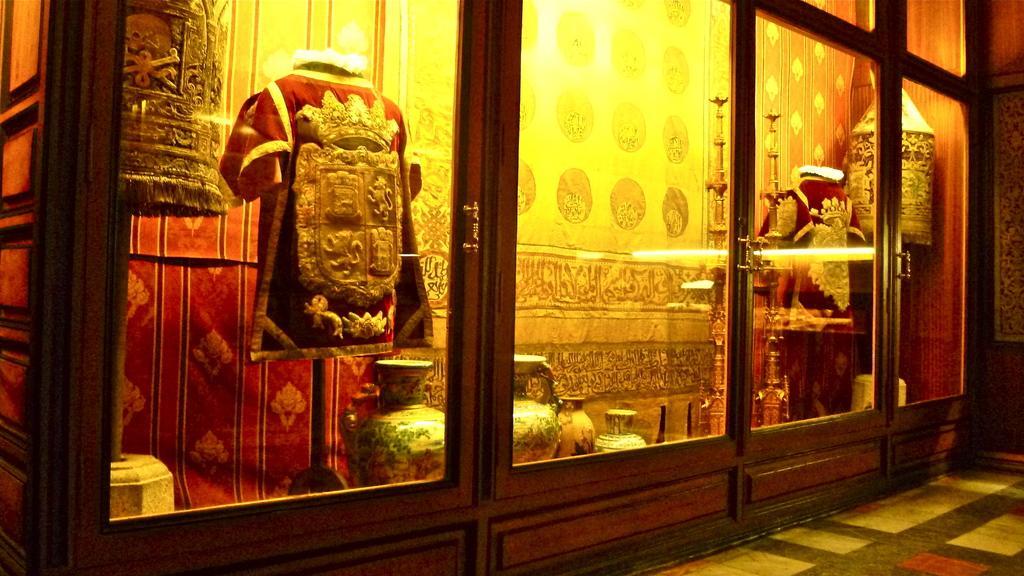Please provide a concise description of this image. In the middle of the image there is a glass door. Behind the door there are red colored costumes and also there are many different pottery vessels on the ground. Behind them to the wall there are curtains hanging. To the right bottom of the image there is a floor. 